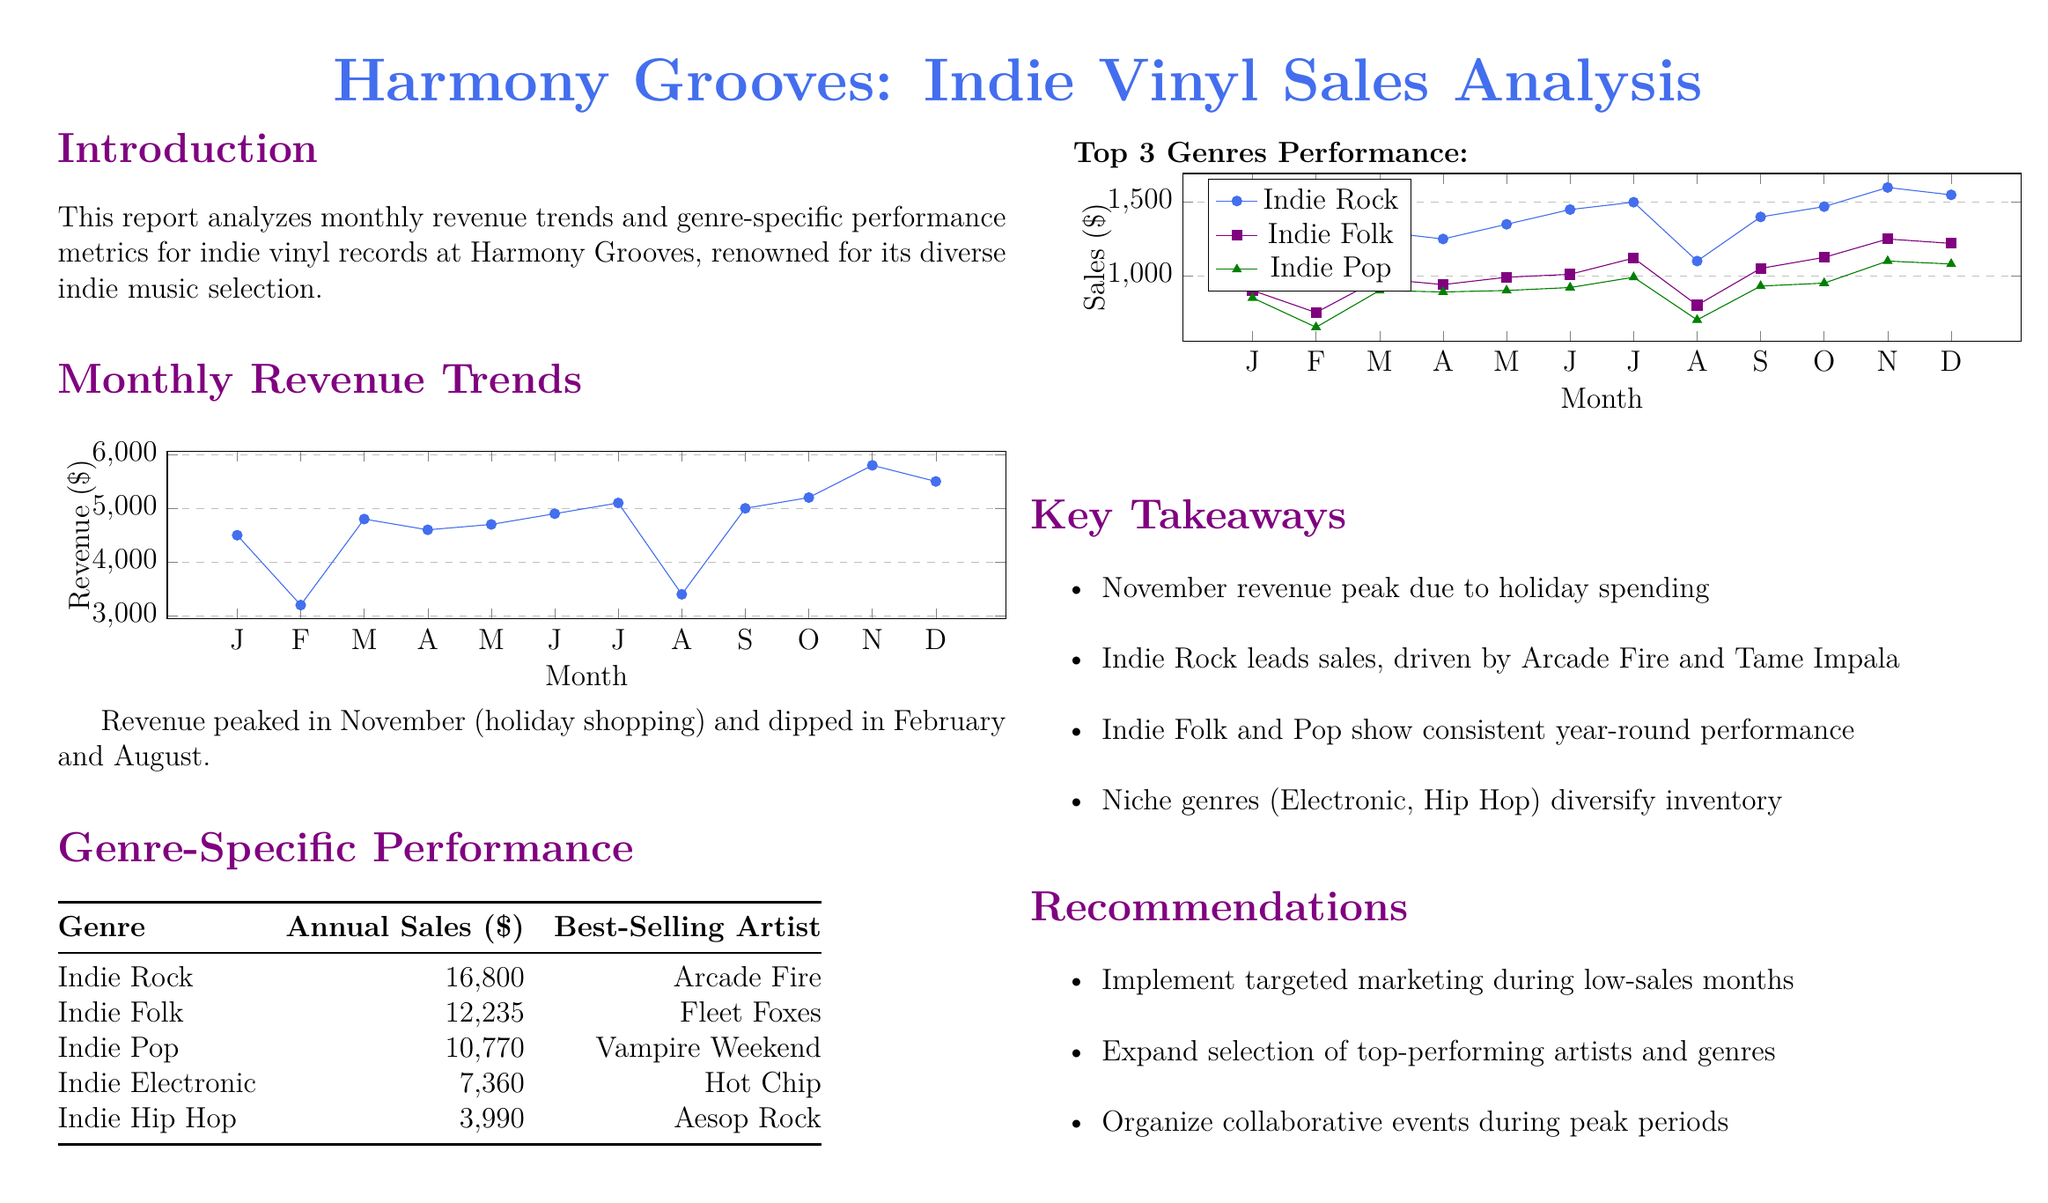What is the highest monthly revenue? The highest monthly revenue is indicated for November, which corresponds to holiday shopping trends.
Answer: $5800 Which genre generated the lowest annual sales? Among the listed genres, Indie Hip Hop had the lowest annual sales figure in the document.
Answer: $3990 What is the best-selling artist for Indie Rock? The best-selling artist for the genre of Indie Rock is specified in the document.
Answer: Arcade Fire In which month did the revenue dip the most? A careful review of the monthly revenue data shows the months of February and August experienced notable dips.
Answer: February What color represents Indie Folk in the sales trend chart? The color assigned to Indie Folk in the visual representation of genre performance is designated in the document.
Answer: Purple How many reviews show a steady annual performance? Looking at the genre analysis, consistent performers can be noted; two genres are highlighted for steady sales.
Answer: 2 What is the recommended strategy during low-sales months? The document suggests implementing specific actions to drive sales during periods of low revenue, which reflects targeted marketing.
Answer: Targeted marketing What was the revenue in March? The monthly revenue trend data provides specific figures for each month, including March.
Answer: $4800 Which genre had the highest annual sales? The document clearly identifies which genre performed best in terms of annual sales, thus revealing its popularity.
Answer: Indie Rock 